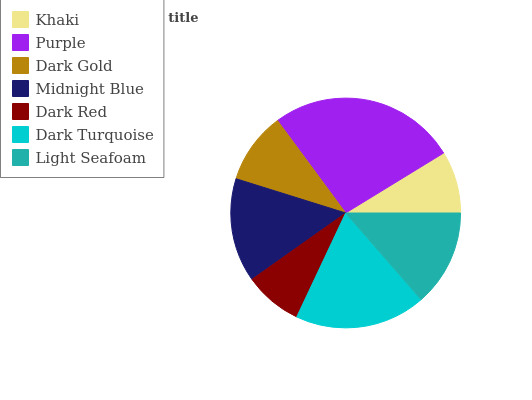Is Dark Red the minimum?
Answer yes or no. Yes. Is Purple the maximum?
Answer yes or no. Yes. Is Dark Gold the minimum?
Answer yes or no. No. Is Dark Gold the maximum?
Answer yes or no. No. Is Purple greater than Dark Gold?
Answer yes or no. Yes. Is Dark Gold less than Purple?
Answer yes or no. Yes. Is Dark Gold greater than Purple?
Answer yes or no. No. Is Purple less than Dark Gold?
Answer yes or no. No. Is Light Seafoam the high median?
Answer yes or no. Yes. Is Light Seafoam the low median?
Answer yes or no. Yes. Is Purple the high median?
Answer yes or no. No. Is Dark Gold the low median?
Answer yes or no. No. 